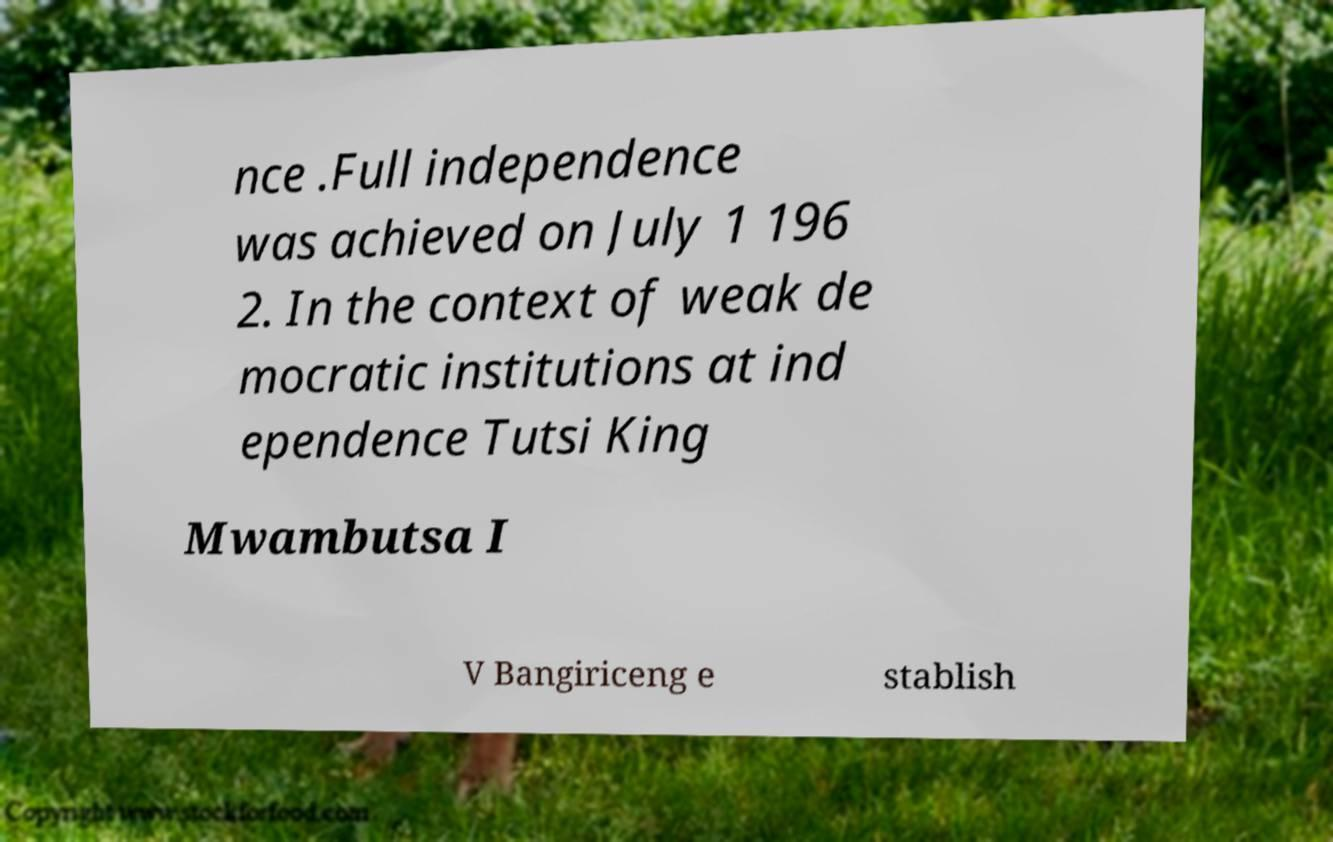Please identify and transcribe the text found in this image. nce .Full independence was achieved on July 1 196 2. In the context of weak de mocratic institutions at ind ependence Tutsi King Mwambutsa I V Bangiriceng e stablish 